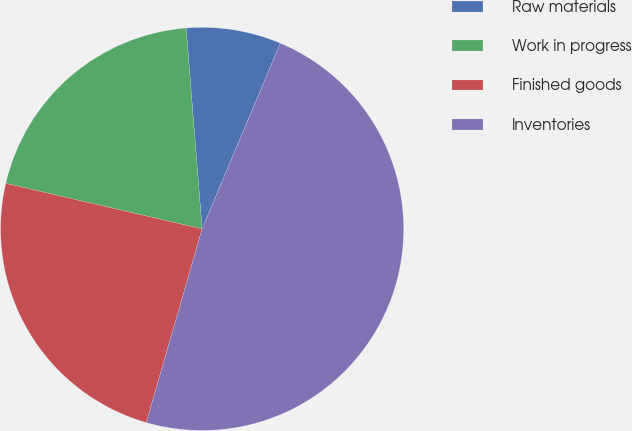<chart> <loc_0><loc_0><loc_500><loc_500><pie_chart><fcel>Raw materials<fcel>Work in progress<fcel>Finished goods<fcel>Inventories<nl><fcel>7.61%<fcel>20.11%<fcel>24.16%<fcel>48.13%<nl></chart> 